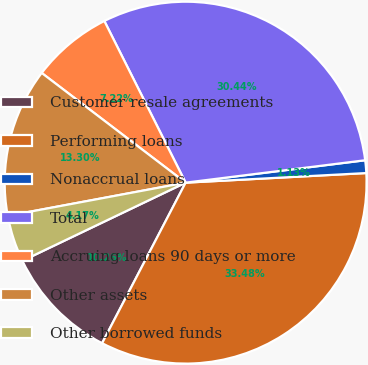Convert chart. <chart><loc_0><loc_0><loc_500><loc_500><pie_chart><fcel>Customer resale agreements<fcel>Performing loans<fcel>Nonaccrual loans<fcel>Total<fcel>Accruing loans 90 days or more<fcel>Other assets<fcel>Other borrowed funds<nl><fcel>10.26%<fcel>33.48%<fcel>1.13%<fcel>30.44%<fcel>7.22%<fcel>13.3%<fcel>4.17%<nl></chart> 